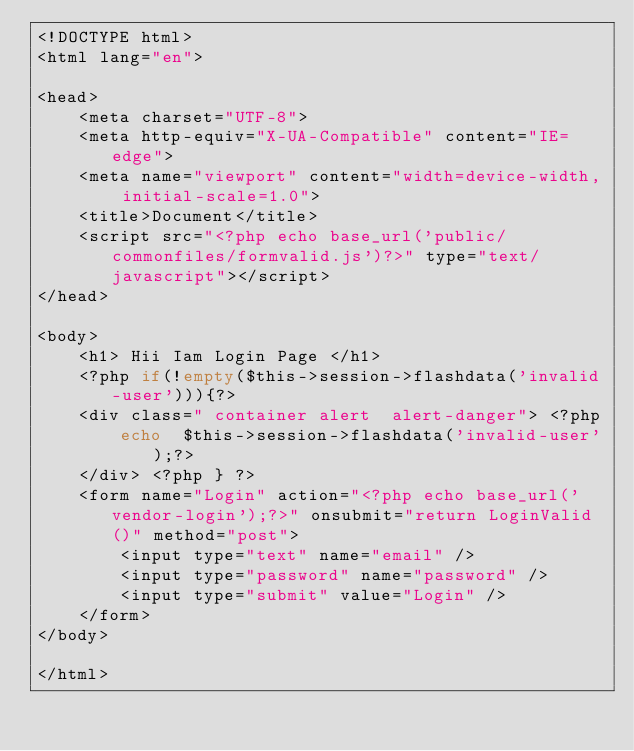Convert code to text. <code><loc_0><loc_0><loc_500><loc_500><_PHP_><!DOCTYPE html>
<html lang="en">

<head>
    <meta charset="UTF-8">
    <meta http-equiv="X-UA-Compatible" content="IE=edge">
    <meta name="viewport" content="width=device-width, initial-scale=1.0">
    <title>Document</title>
    <script src="<?php echo base_url('public/commonfiles/formvalid.js')?>" type="text/javascript"></script>
</head>

<body>
    <h1> Hii Iam Login Page </h1>
    <?php if(!empty($this->session->flashdata('invalid-user'))){?>
    <div class=" container alert  alert-danger"> <?php
        echo  $this->session->flashdata('invalid-user');?>
    </div> <?php } ?>
    <form name="Login" action="<?php echo base_url('vendor-login');?>" onsubmit="return LoginValid()" method="post">
        <input type="text" name="email" />
        <input type="password" name="password" />
        <input type="submit" value="Login" />
    </form>
</body>

</html></code> 